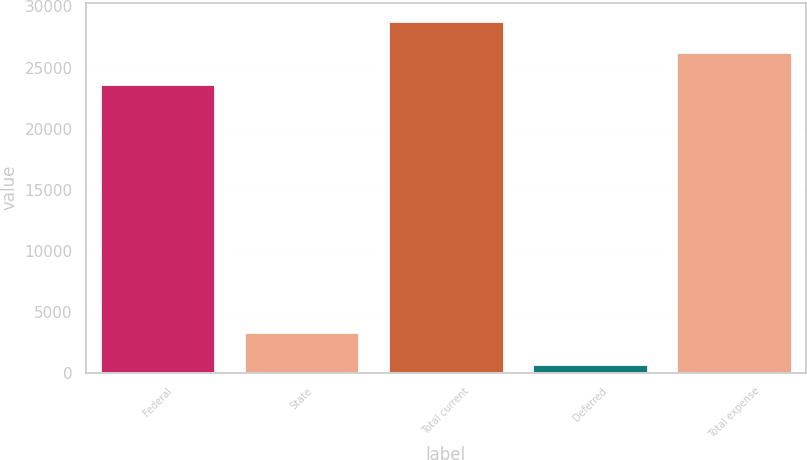Convert chart. <chart><loc_0><loc_0><loc_500><loc_500><bar_chart><fcel>Federal<fcel>State<fcel>Total current<fcel>Deferred<fcel>Total expense<nl><fcel>23652<fcel>3312.5<fcel>28847<fcel>715<fcel>26249.5<nl></chart> 